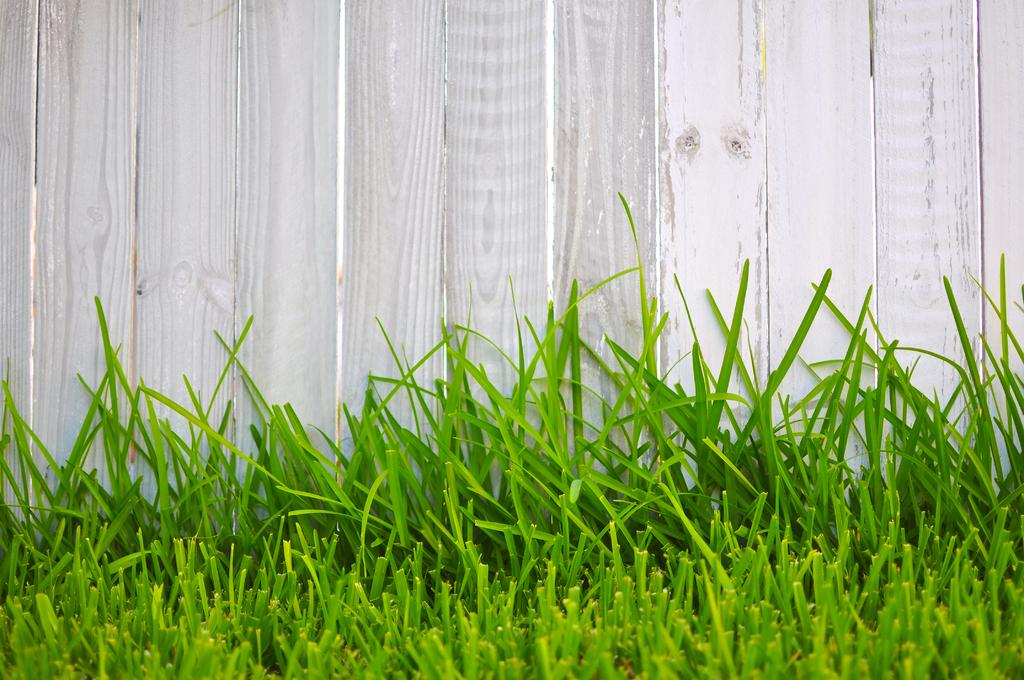What type of vegetation is present in the image? There is grass in the image. What is the color of the grass? The grass is green. What type of structure is visible in the image? There is a wooden wall in the image. What is the color of the wooden wall? The wooden wall is white. How does the goose interact with the wooden wall in the image? There is no goose present in the image, so it cannot interact with the wooden wall. What suggestion does the pest make to the grass in the image? There is no pest or suggestion present in the image; it only features grass and a wooden wall. 